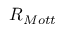Convert formula to latex. <formula><loc_0><loc_0><loc_500><loc_500>R _ { M o t t }</formula> 